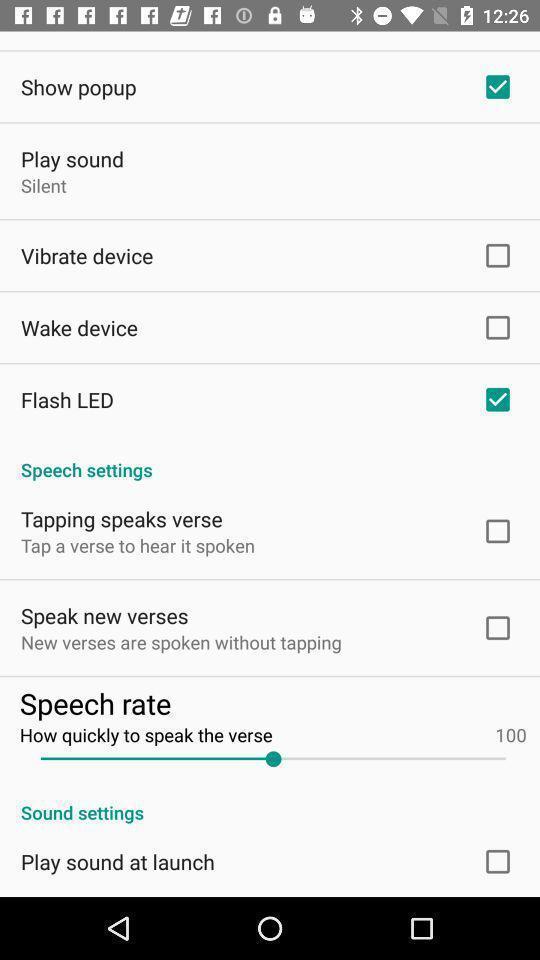Describe the content in this image. Screen shows settings and other options in a prayer application. 